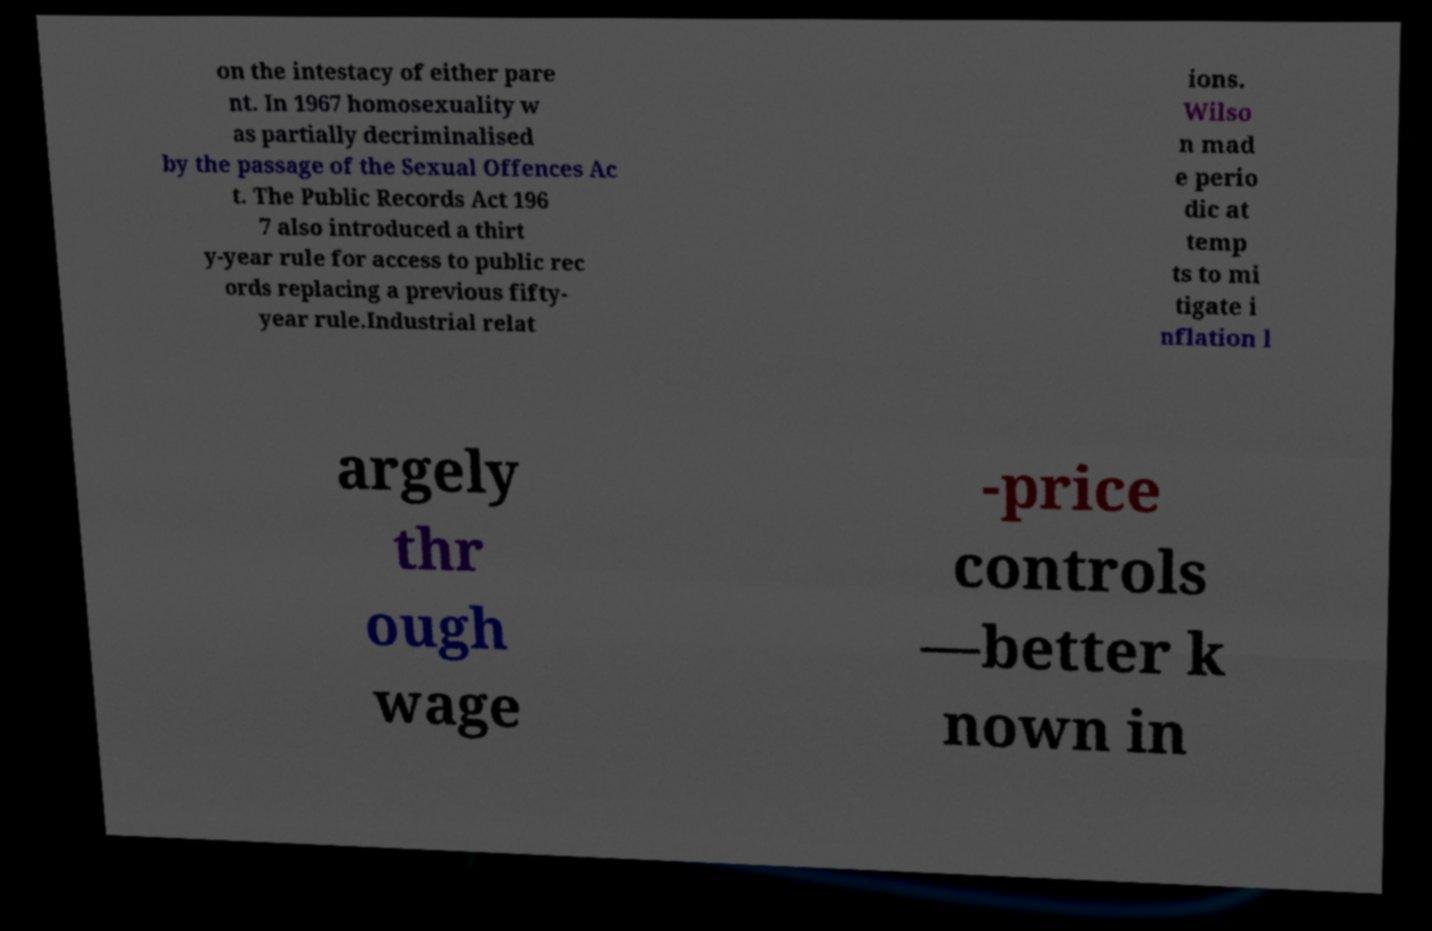Please identify and transcribe the text found in this image. on the intestacy of either pare nt. In 1967 homosexuality w as partially decriminalised by the passage of the Sexual Offences Ac t. The Public Records Act 196 7 also introduced a thirt y-year rule for access to public rec ords replacing a previous fifty- year rule.Industrial relat ions. Wilso n mad e perio dic at temp ts to mi tigate i nflation l argely thr ough wage -price controls —better k nown in 